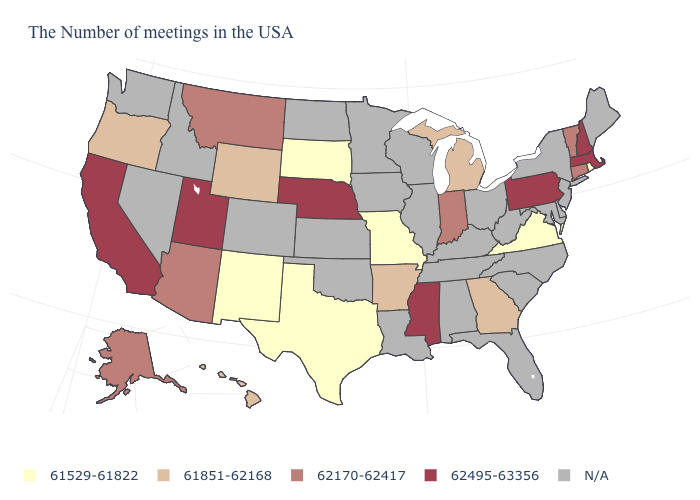Among the states that border Illinois , does Missouri have the lowest value?
Quick response, please. Yes. What is the value of Hawaii?
Answer briefly. 61851-62168. Name the states that have a value in the range 61529-61822?
Keep it brief. Rhode Island, Virginia, Missouri, Texas, South Dakota, New Mexico. What is the value of New York?
Concise answer only. N/A. Which states have the highest value in the USA?
Be succinct. Massachusetts, New Hampshire, Pennsylvania, Mississippi, Nebraska, Utah, California. Name the states that have a value in the range N/A?
Give a very brief answer. Maine, New York, New Jersey, Delaware, Maryland, North Carolina, South Carolina, West Virginia, Ohio, Florida, Kentucky, Alabama, Tennessee, Wisconsin, Illinois, Louisiana, Minnesota, Iowa, Kansas, Oklahoma, North Dakota, Colorado, Idaho, Nevada, Washington. Does Pennsylvania have the lowest value in the USA?
Be succinct. No. What is the value of Alaska?
Write a very short answer. 62170-62417. What is the value of Nebraska?
Answer briefly. 62495-63356. What is the highest value in states that border Kentucky?
Give a very brief answer. 62170-62417. What is the value of Texas?
Be succinct. 61529-61822. What is the value of Montana?
Be succinct. 62170-62417. Name the states that have a value in the range 62170-62417?
Concise answer only. Vermont, Connecticut, Indiana, Montana, Arizona, Alaska. What is the value of Illinois?
Write a very short answer. N/A. 